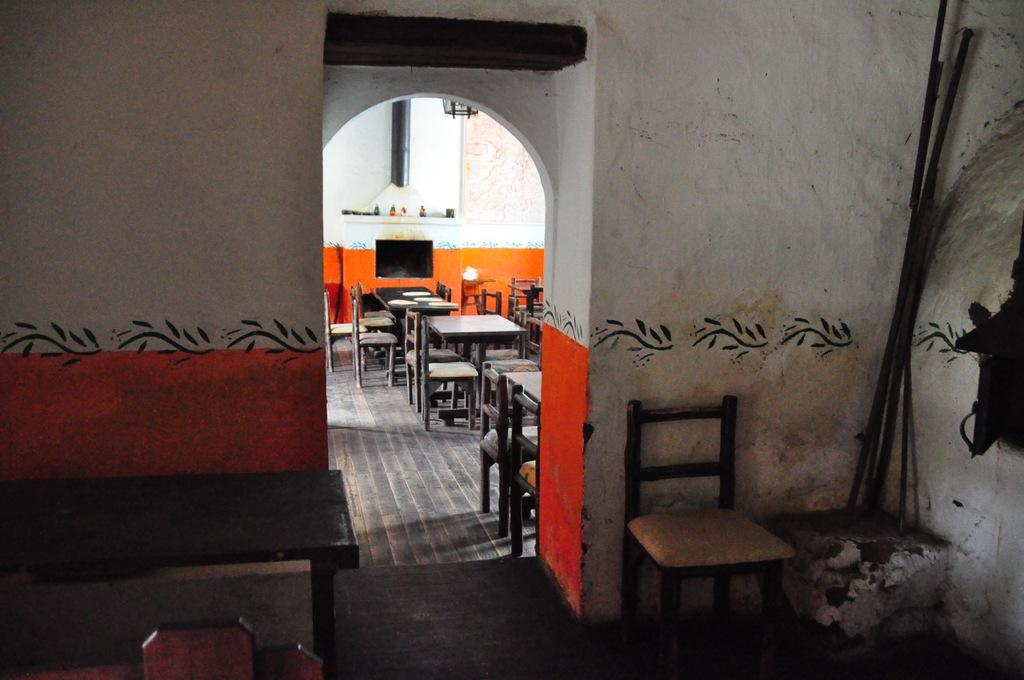What type of furniture is present in the image? There are tables and chairs in the image. Where are the tables and chairs located? The tables and chairs are on the floor. What can be seen on the wall in the image? There is a TV and paintings on the wall. What reason does the father give for wearing a ring in the image? There is no father or ring present in the image, so it is not possible to answer that question. 